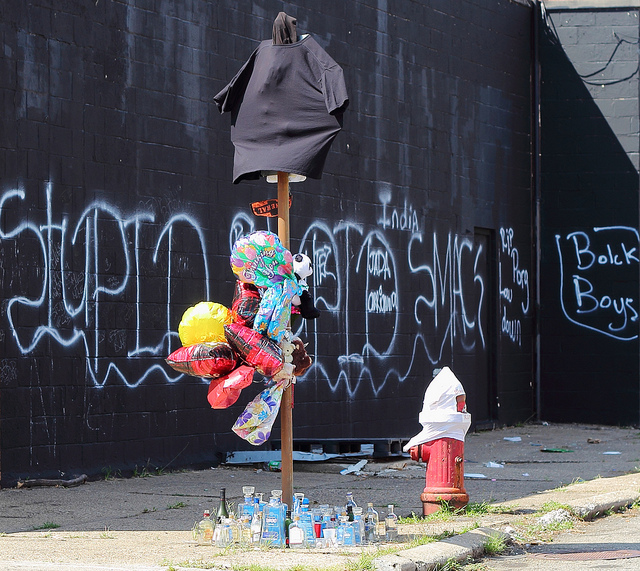Please transcribe the text in this image. Bolck Boys IndiA SMAC STUPID STUPID 